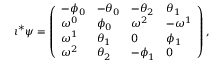Convert formula to latex. <formula><loc_0><loc_0><loc_500><loc_500>\iota ^ { * } \psi = \left ( \begin{array} { l l l l } { - \phi _ { 0 } } & { - \theta _ { 0 } } & { - \theta _ { 2 } } & { \theta _ { 1 } } \\ { \omega ^ { 0 } } & { \phi _ { 0 } } & { \omega ^ { 2 } } & { - \omega ^ { 1 } } \\ { \omega ^ { 1 } } & { \theta _ { 1 } } & { 0 } & { \phi _ { 1 } } \\ { \omega ^ { 2 } } & { \theta _ { 2 } } & { - \phi _ { 1 } } & { 0 } \end{array} \right ) ,</formula> 